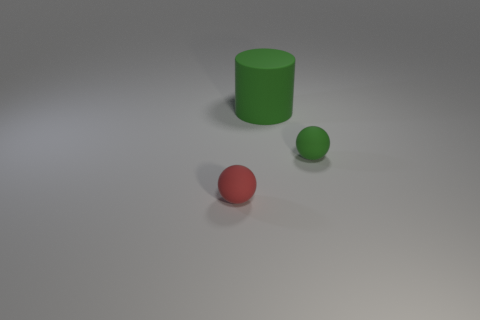Add 1 tiny metallic cubes. How many objects exist? 4 Subtract all cylinders. How many objects are left? 2 Add 3 large matte things. How many large matte things exist? 4 Subtract 0 red cylinders. How many objects are left? 3 Subtract all tiny things. Subtract all large cyan shiny blocks. How many objects are left? 1 Add 2 rubber objects. How many rubber objects are left? 5 